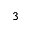<formula> <loc_0><loc_0><loc_500><loc_500>_ { 3 }</formula> 